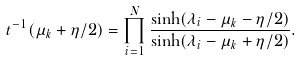Convert formula to latex. <formula><loc_0><loc_0><loc_500><loc_500>t ^ { - 1 } ( \mu _ { k } + \eta / 2 ) = \prod _ { i = 1 } ^ { N } \frac { \sinh ( \lambda _ { i } - \mu _ { k } - \eta / 2 ) } { \sinh ( \lambda _ { i } - \mu _ { k } + \eta / 2 ) } .</formula> 